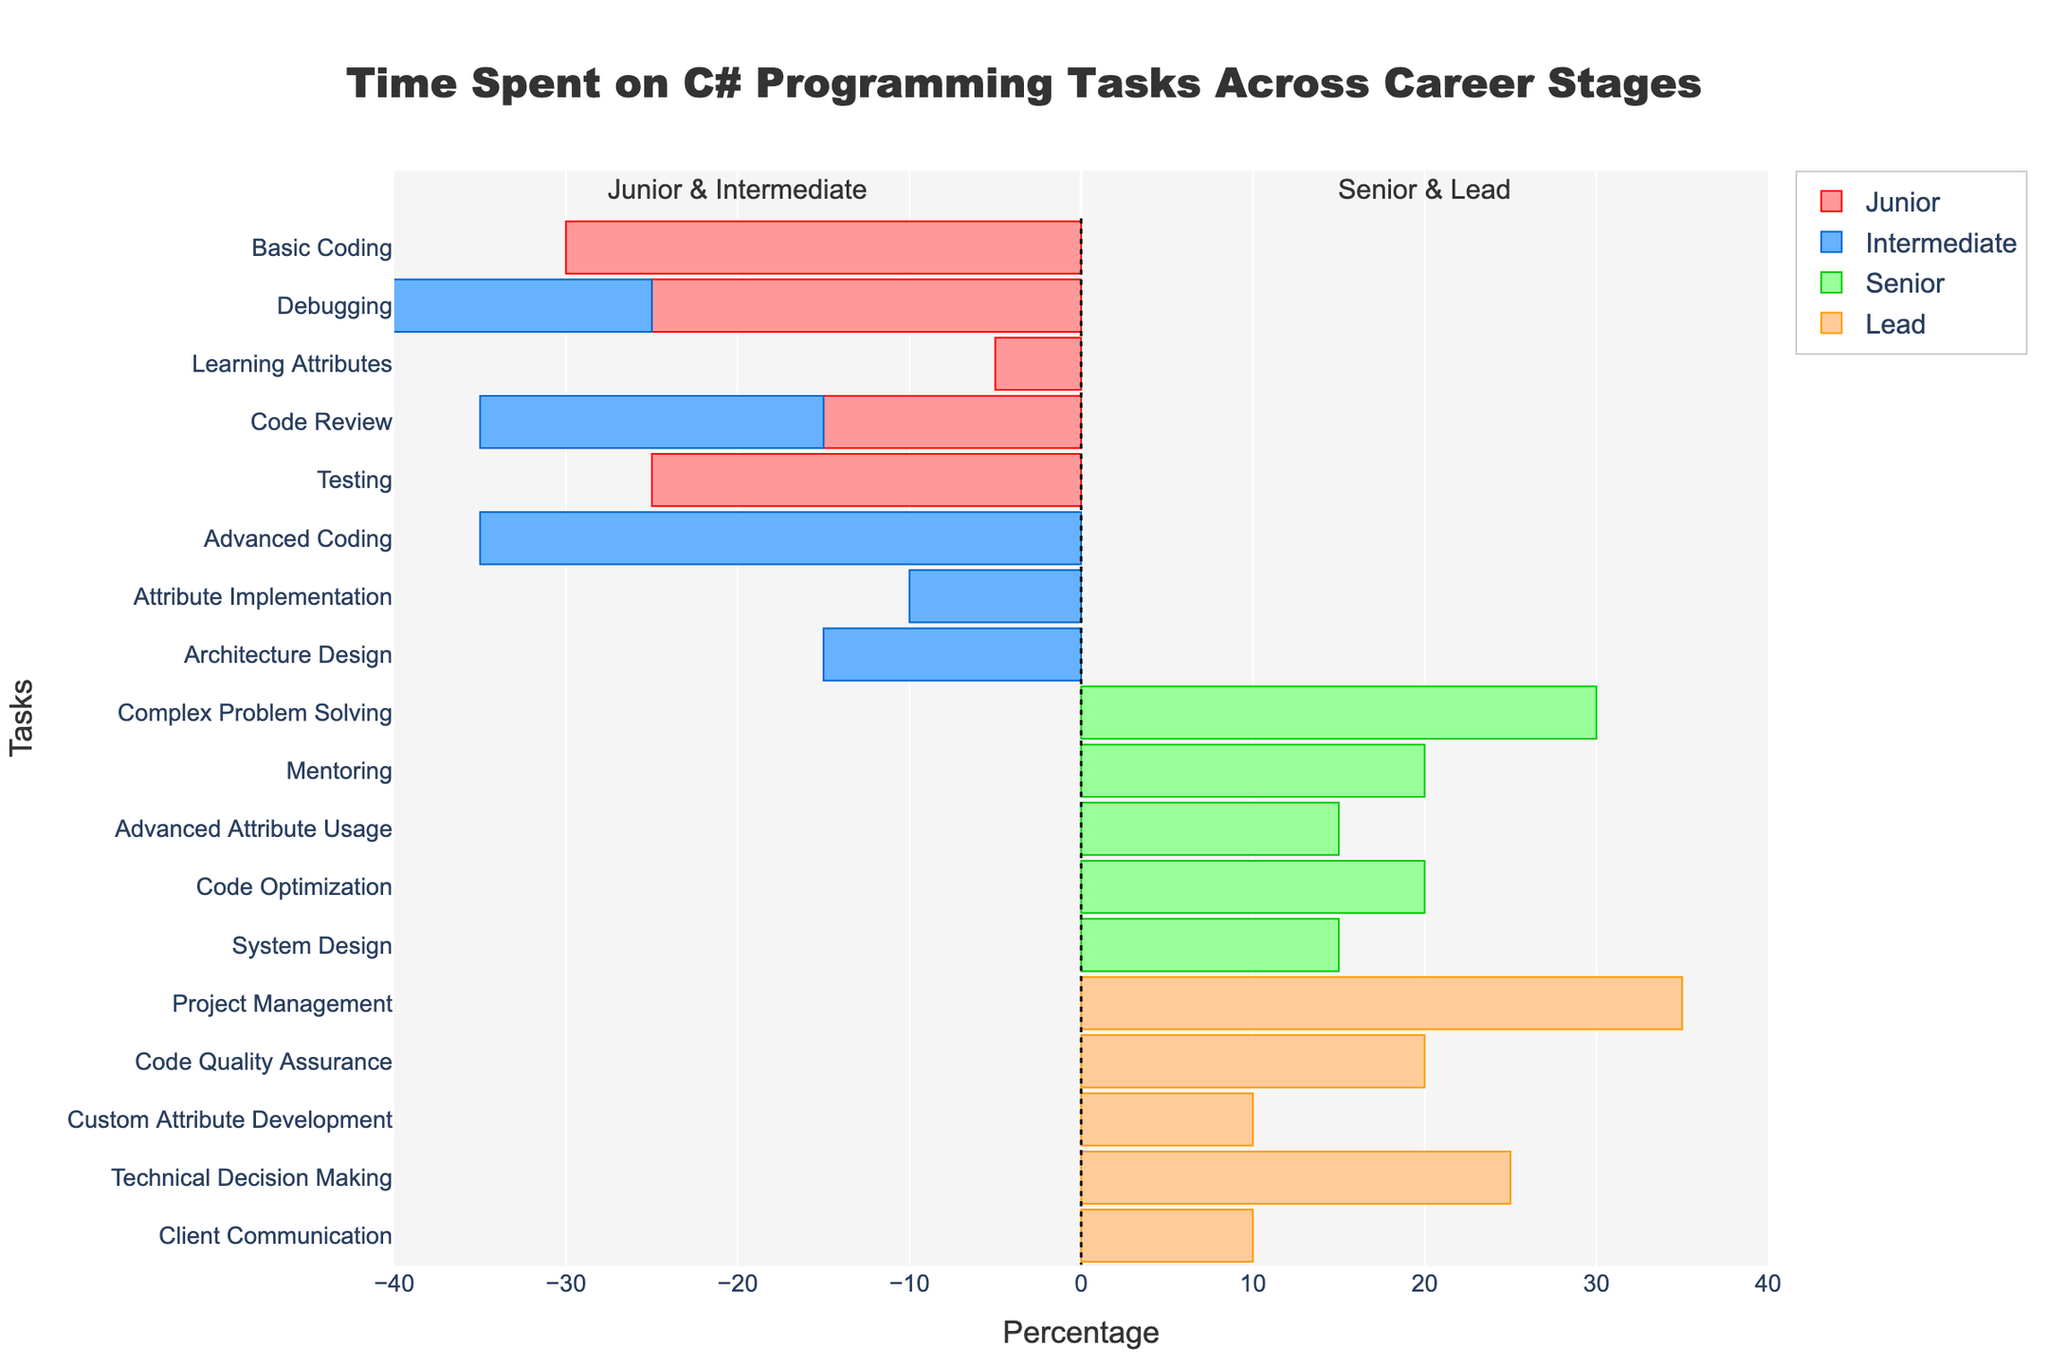What is the title of the figure? The title of the figure is displayed prominently at the top.
Answer: Time Spent on C# Programming Tasks Across Career Stages How many tasks are associated with the Intermediate career stage? The Intermediate career stage has tasks listed in the pyramid plot, count the number of distinct tasks labeled for Intermediate.
Answer: 5 Which career stage spends the highest percentage of time on a single task, and what is that task? Identify the task with the maximum bar length for each career stage and compare them.
Answer: Lead, Project Management (35%) What percentage of time do Junior and Intermediate developers spend on Learning Attributes and Attribute Implementation combined? Add the percentages of Learning Attributes (5%) and Attribute Implementation (10%) for Junior and Intermediate developers, respectively.
Answer: 15% Which career stage is involved in Custom Attribute Development, and what percentage of their time do they dedicate to it? Look for the task "Custom Attribute Development" and determine which career stage has this task along with its percentage.
Answer: Lead, 10% What is the difference in the percentage of time spent on Debugging between Junior and Intermediate developers? Subtract the percentage of time spent on Debugging by Intermediate developers from that of Junior developers (25% - 20%).
Answer: 5% How does the percentage of time spent on Code Review compare between Juniors and Intermediates? Look at the bar lengths for Code Review in both Junior and Intermediate stages and compare them.
Answer: Same (20%) Which task is most significant for Senior developers compared to other career stages? Identify the task with the longest bar for Senior developers and check other career stages for comparison.
Answer: Complex Problem Solving (30%) What's the combined percentage of time spent on Technical Decision Making and Client Communication by Lead developers? Sum the percentages for Technical Decision Making (25%) and Client Communication (10%) for Lead developers.
Answer: 35% What tasks do the most experienced developers (Lead) spend the least percentage of time on, and by how much compared to their highest percentage task? Identify the task with the shortest bar for Lead developers and compare it to the longest bar (35% - 10%).
Answer: Client Communication, 25% 